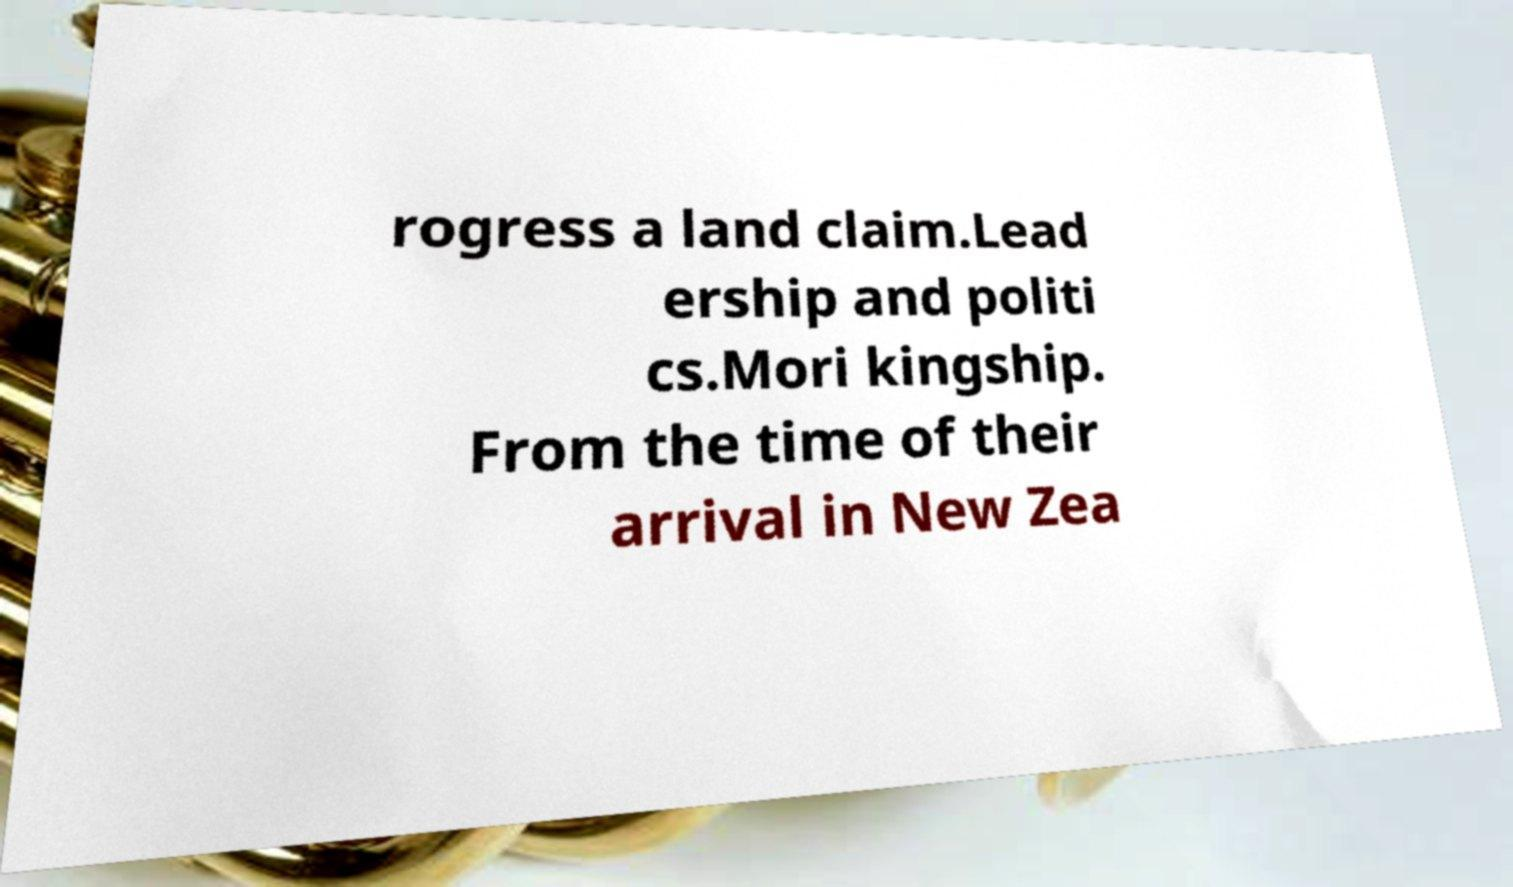There's text embedded in this image that I need extracted. Can you transcribe it verbatim? rogress a land claim.Lead ership and politi cs.Mori kingship. From the time of their arrival in New Zea 